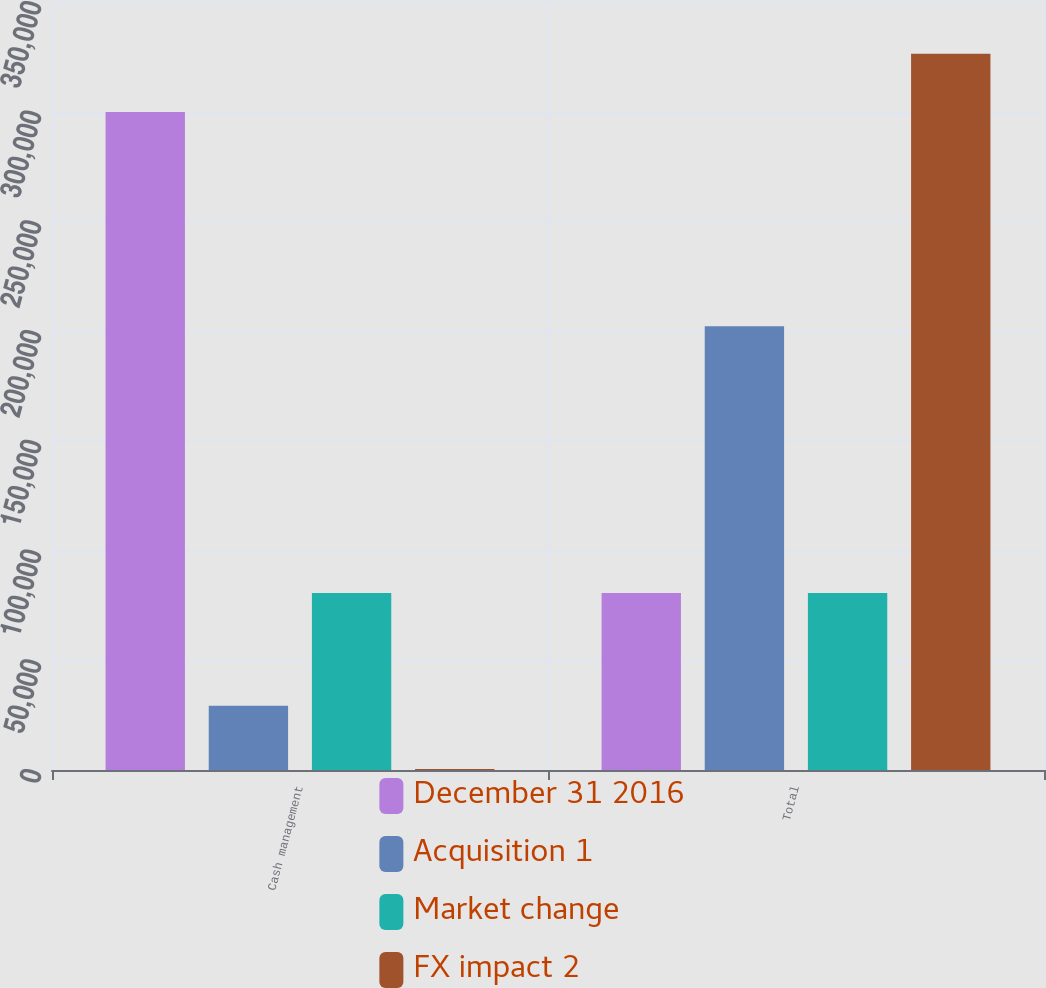Convert chart to OTSL. <chart><loc_0><loc_0><loc_500><loc_500><stacked_bar_chart><ecel><fcel>Cash management<fcel>Total<nl><fcel>December 31 2016<fcel>299884<fcel>80635<nl><fcel>Acquisition 1<fcel>29228<fcel>202191<nl><fcel>Market change<fcel>80635<fcel>80635<nl><fcel>FX impact 2<fcel>430<fcel>326364<nl></chart> 